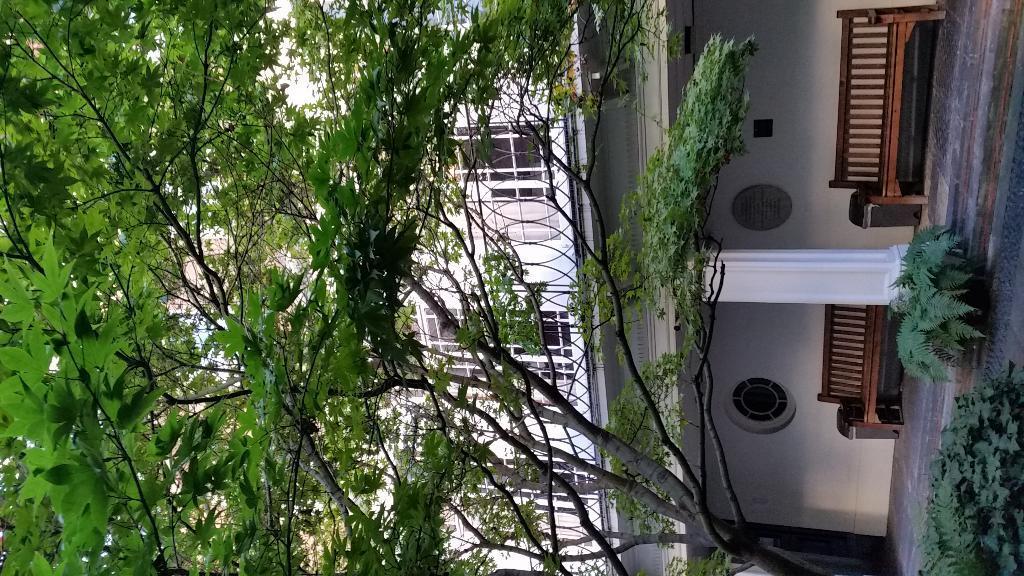Can you describe this image briefly? In the left side there are trees and here these are the sitting bench chairs and this is a building which is in white color. 